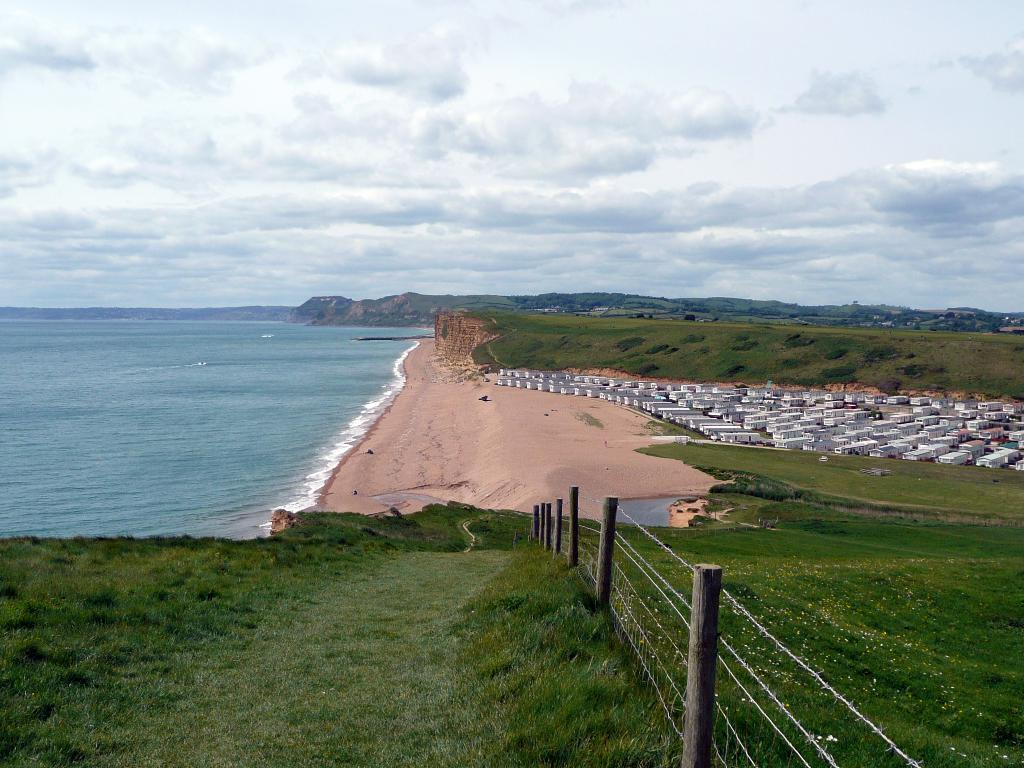What type of barrier can be seen in the image? There is a fence in the image. What type of vegetation is present in the image? There is grass in the image. What type of structures can be seen in the image? There are houses in the image. What natural feature is visible in the image? There is water visible in the image. What type of plant life is present in the image? There are trees in the image. What type of geographical feature can be seen in the image? There are hills in the image. What is visible in the background of the image? The sky is visible in the background of the image. Where is the tray of bread located in the image? There is no tray of bread present in the image. What type of transportation station can be seen in the image? There is no transportation station present in the image. 